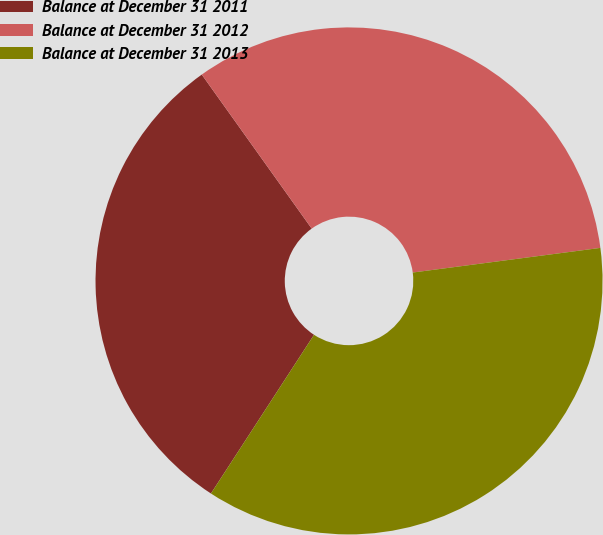Convert chart. <chart><loc_0><loc_0><loc_500><loc_500><pie_chart><fcel>Balance at December 31 2011<fcel>Balance at December 31 2012<fcel>Balance at December 31 2013<nl><fcel>30.97%<fcel>32.79%<fcel>36.25%<nl></chart> 